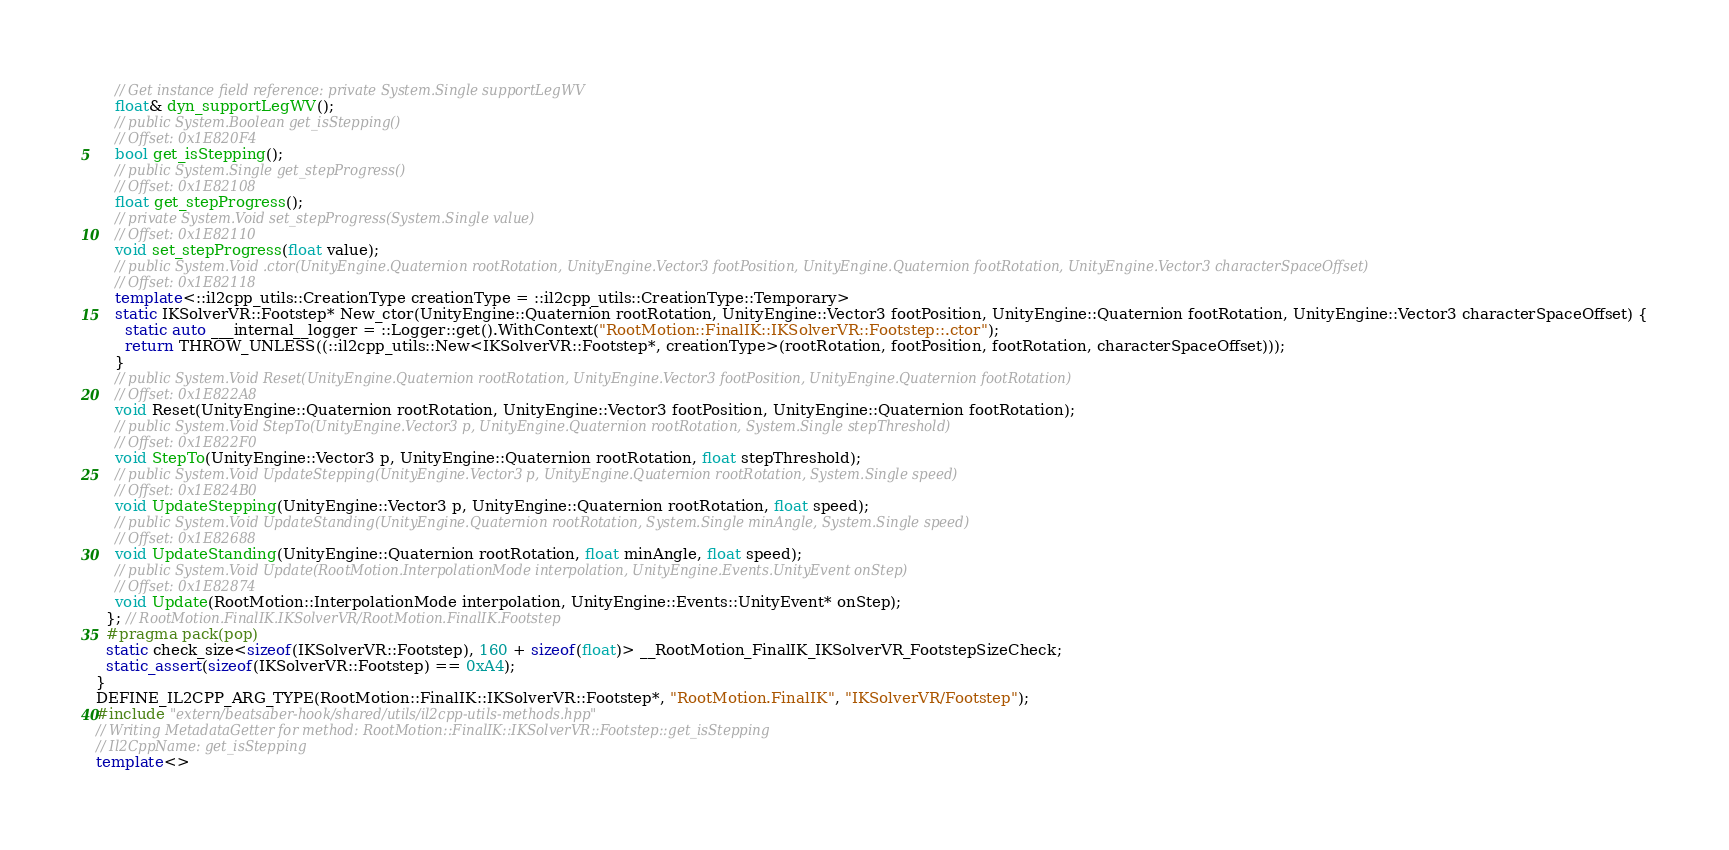Convert code to text. <code><loc_0><loc_0><loc_500><loc_500><_C++_>    // Get instance field reference: private System.Single supportLegWV
    float& dyn_supportLegWV();
    // public System.Boolean get_isStepping()
    // Offset: 0x1E820F4
    bool get_isStepping();
    // public System.Single get_stepProgress()
    // Offset: 0x1E82108
    float get_stepProgress();
    // private System.Void set_stepProgress(System.Single value)
    // Offset: 0x1E82110
    void set_stepProgress(float value);
    // public System.Void .ctor(UnityEngine.Quaternion rootRotation, UnityEngine.Vector3 footPosition, UnityEngine.Quaternion footRotation, UnityEngine.Vector3 characterSpaceOffset)
    // Offset: 0x1E82118
    template<::il2cpp_utils::CreationType creationType = ::il2cpp_utils::CreationType::Temporary>
    static IKSolverVR::Footstep* New_ctor(UnityEngine::Quaternion rootRotation, UnityEngine::Vector3 footPosition, UnityEngine::Quaternion footRotation, UnityEngine::Vector3 characterSpaceOffset) {
      static auto ___internal__logger = ::Logger::get().WithContext("RootMotion::FinalIK::IKSolverVR::Footstep::.ctor");
      return THROW_UNLESS((::il2cpp_utils::New<IKSolverVR::Footstep*, creationType>(rootRotation, footPosition, footRotation, characterSpaceOffset)));
    }
    // public System.Void Reset(UnityEngine.Quaternion rootRotation, UnityEngine.Vector3 footPosition, UnityEngine.Quaternion footRotation)
    // Offset: 0x1E822A8
    void Reset(UnityEngine::Quaternion rootRotation, UnityEngine::Vector3 footPosition, UnityEngine::Quaternion footRotation);
    // public System.Void StepTo(UnityEngine.Vector3 p, UnityEngine.Quaternion rootRotation, System.Single stepThreshold)
    // Offset: 0x1E822F0
    void StepTo(UnityEngine::Vector3 p, UnityEngine::Quaternion rootRotation, float stepThreshold);
    // public System.Void UpdateStepping(UnityEngine.Vector3 p, UnityEngine.Quaternion rootRotation, System.Single speed)
    // Offset: 0x1E824B0
    void UpdateStepping(UnityEngine::Vector3 p, UnityEngine::Quaternion rootRotation, float speed);
    // public System.Void UpdateStanding(UnityEngine.Quaternion rootRotation, System.Single minAngle, System.Single speed)
    // Offset: 0x1E82688
    void UpdateStanding(UnityEngine::Quaternion rootRotation, float minAngle, float speed);
    // public System.Void Update(RootMotion.InterpolationMode interpolation, UnityEngine.Events.UnityEvent onStep)
    // Offset: 0x1E82874
    void Update(RootMotion::InterpolationMode interpolation, UnityEngine::Events::UnityEvent* onStep);
  }; // RootMotion.FinalIK.IKSolverVR/RootMotion.FinalIK.Footstep
  #pragma pack(pop)
  static check_size<sizeof(IKSolverVR::Footstep), 160 + sizeof(float)> __RootMotion_FinalIK_IKSolverVR_FootstepSizeCheck;
  static_assert(sizeof(IKSolverVR::Footstep) == 0xA4);
}
DEFINE_IL2CPP_ARG_TYPE(RootMotion::FinalIK::IKSolverVR::Footstep*, "RootMotion.FinalIK", "IKSolverVR/Footstep");
#include "extern/beatsaber-hook/shared/utils/il2cpp-utils-methods.hpp"
// Writing MetadataGetter for method: RootMotion::FinalIK::IKSolverVR::Footstep::get_isStepping
// Il2CppName: get_isStepping
template<></code> 